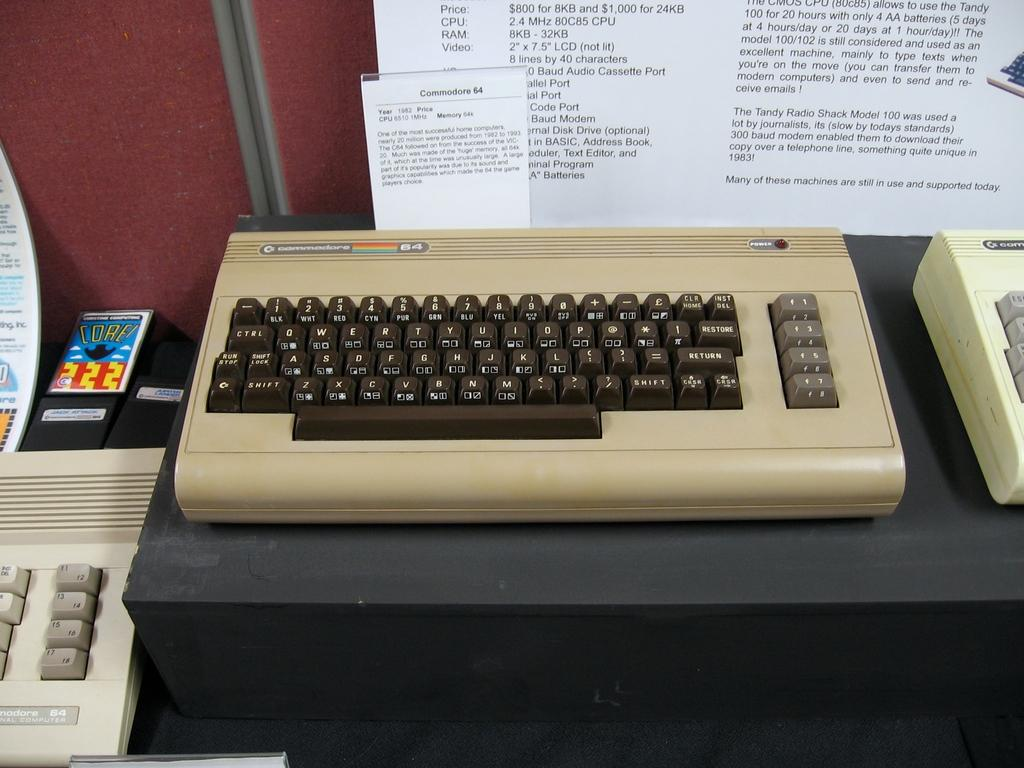<image>
Share a concise interpretation of the image provided. A Commodore 64 keyboard with a piece of paper behind it 